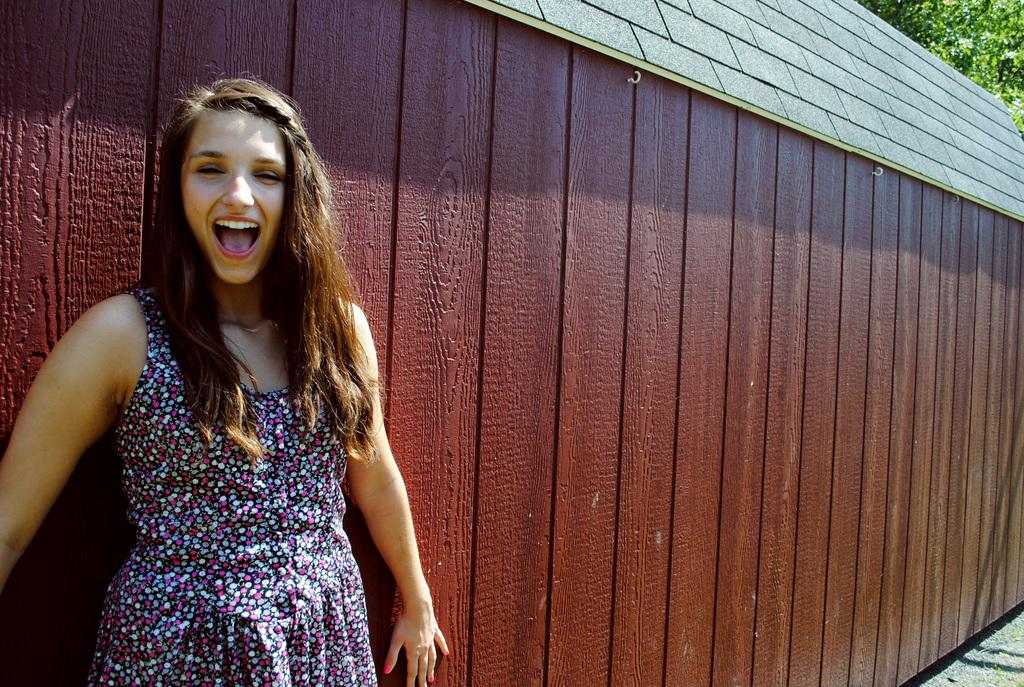Who is present in the image? There is a woman in the image. What is the woman doing in the image? The woman is standing and smiling. What structure can be seen in the image? There is a shed in the image. What type of vegetation is visible in the image? There is a tree in the top right corner of the image. What type of bell can be heard ringing in the image? There is no bell present in the image, and therefore no sound can be heard. What kind of pet is accompanying the woman in the image? There is no pet visible in the image. 